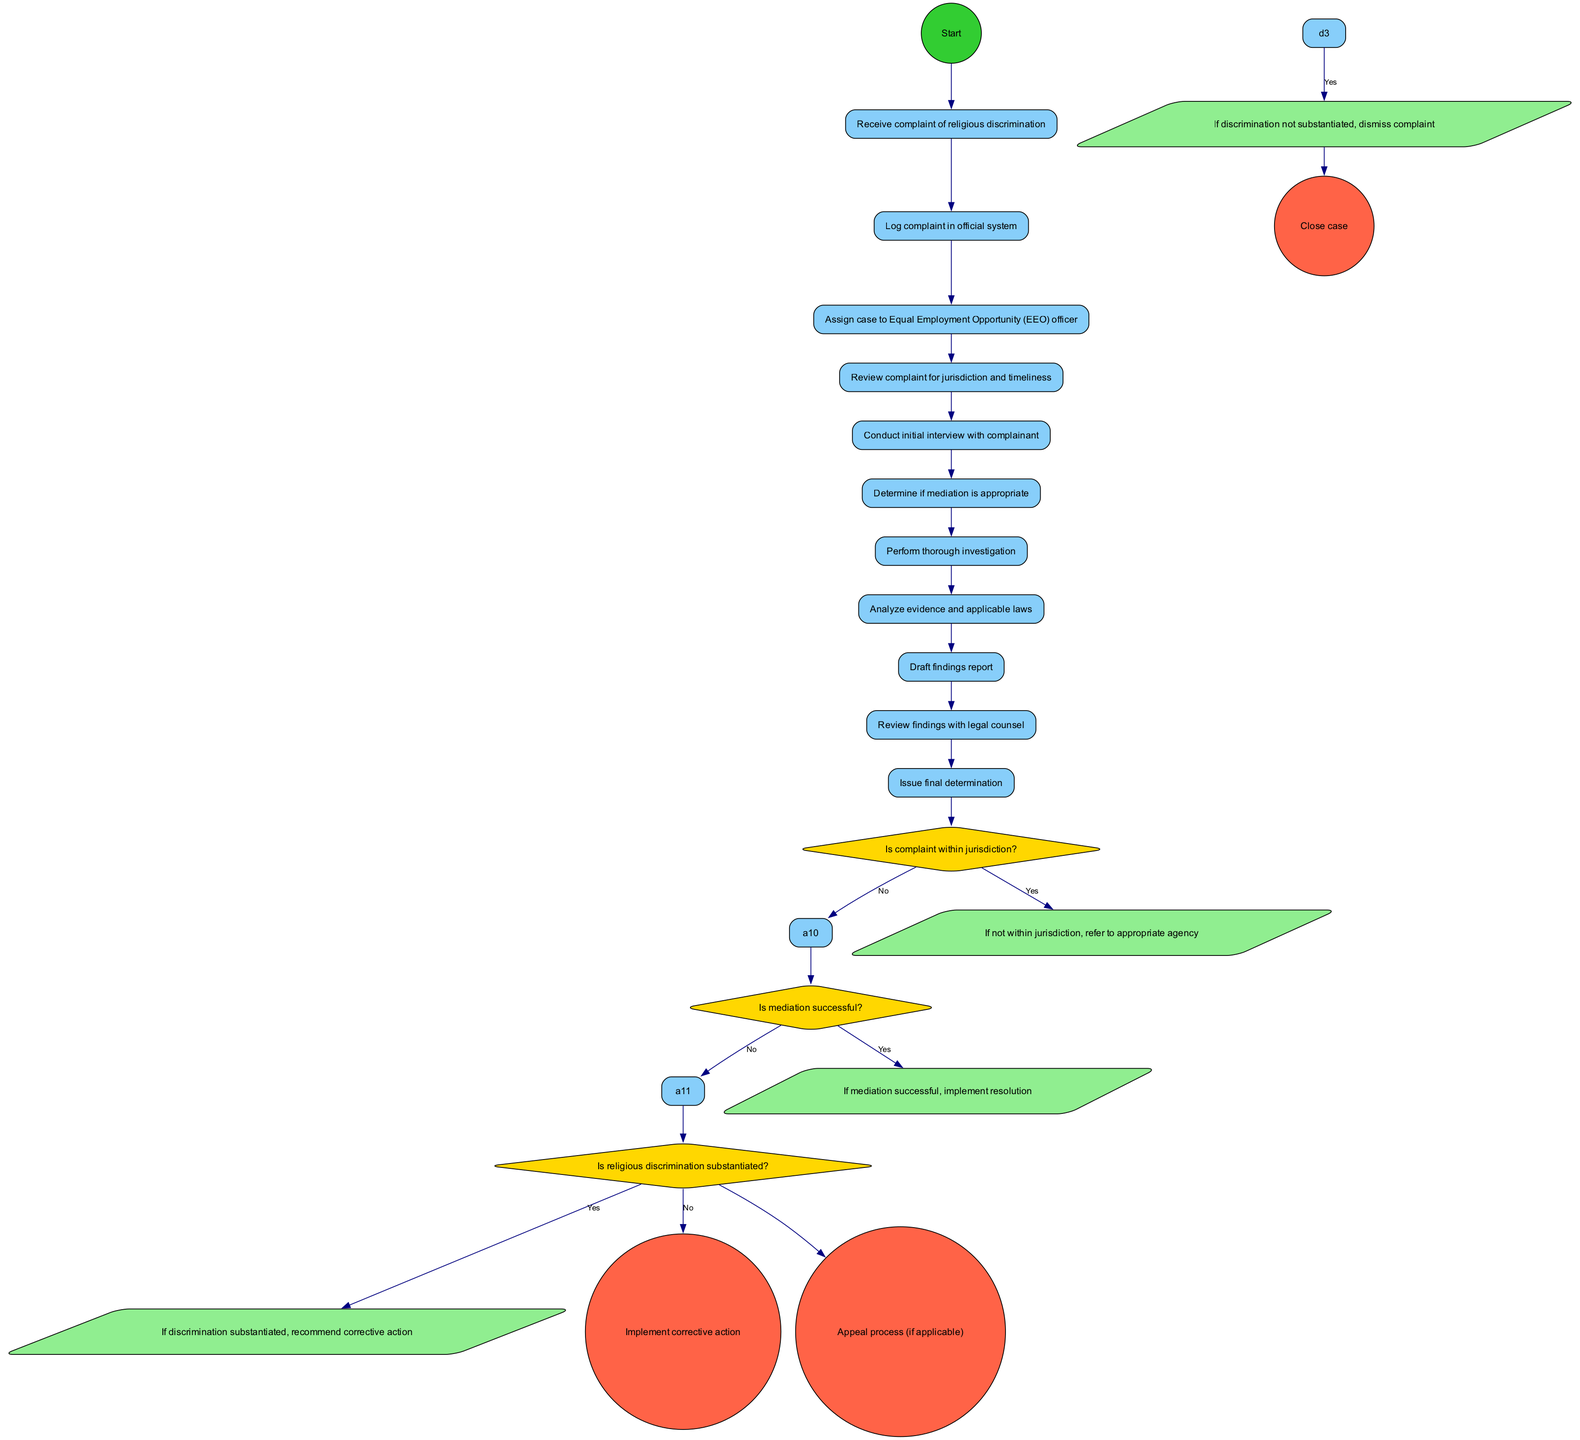What is the first activity after receiving the complaint? The first activity listed in the diagram after the initial step of receiving the complaint is "Log complaint in official system". This is the immediate action that follows the start of the process.
Answer: Log complaint in official system How many activities are there in total? The diagram lists a total of 10 activities from start to finish, as counted sequentially through the list of activities provided.
Answer: 10 What decision follows the initial interview with the complainant? After the "Conduct initial interview with complainant", the next decision node is "Determine if mediation is appropriate". This follows logically as a consideration on how to handle the case further.
Answer: Determine if mediation is appropriate If the complaint is not within jurisdiction, what step is taken? If the complaint is determined not to be within jurisdiction, the flow specifies that it will redirect or refer the complaint to the appropriate agency, which is outlined in the flow associated with that decision.
Answer: Refer to appropriate agency How many end nodes are present in the diagram? There are three end nodes listed in the diagram, which outline the possible conclusions of the procedure: "Close case", "Implement corrective action", and "Appeal process (if applicable)".
Answer: 3 What happens if mediation is successful? If mediation is successful, the flow indicates that the resolution will be implemented as the next step, showing that the case will be resolved positively after mediation.
Answer: Implement resolution Is there a step for reviewing findings with legal counsel? Yes, there is a step specifically titled "Review findings with legal counsel," which indicates a decision-making process that involves consulting legal guidance before issuing a final determination.
Answer: Yes What is the outcome if discrimination is not substantiated? If it’s determined that the discrimination is not substantiated, the subsequent action defined in the diagram is to dismiss the complaint, which concludes that no further action is required.
Answer: Dismiss complaint 